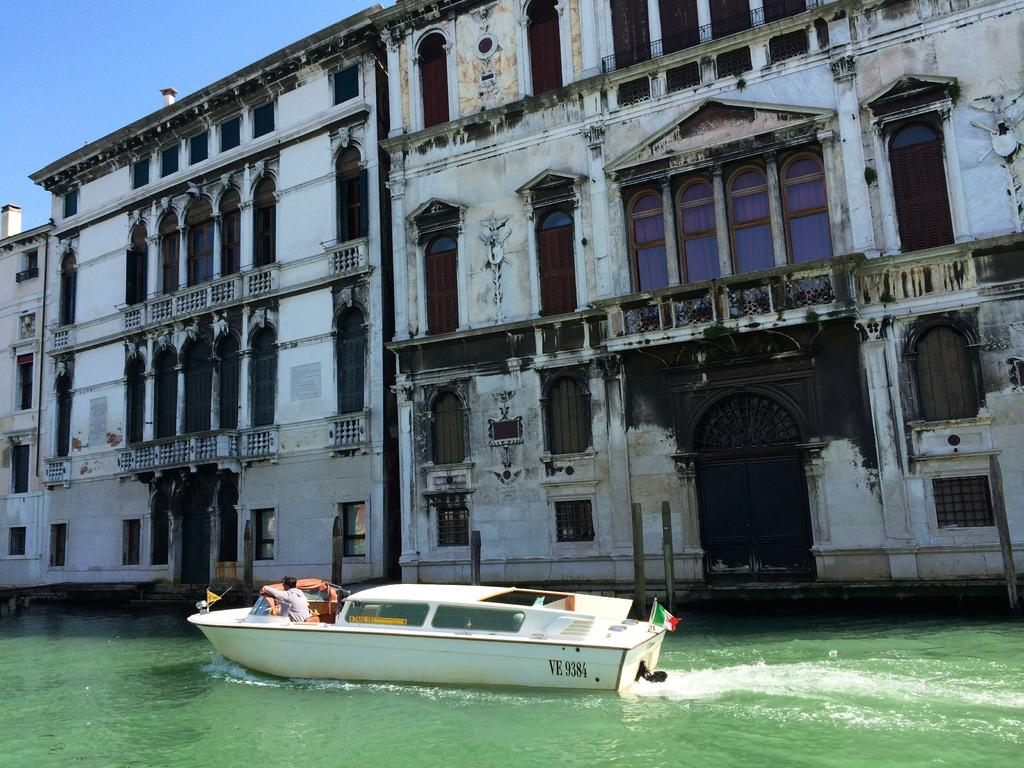<image>
Render a clear and concise summary of the photo. A boat, which is marked VE 9384, travels through a waterway. 